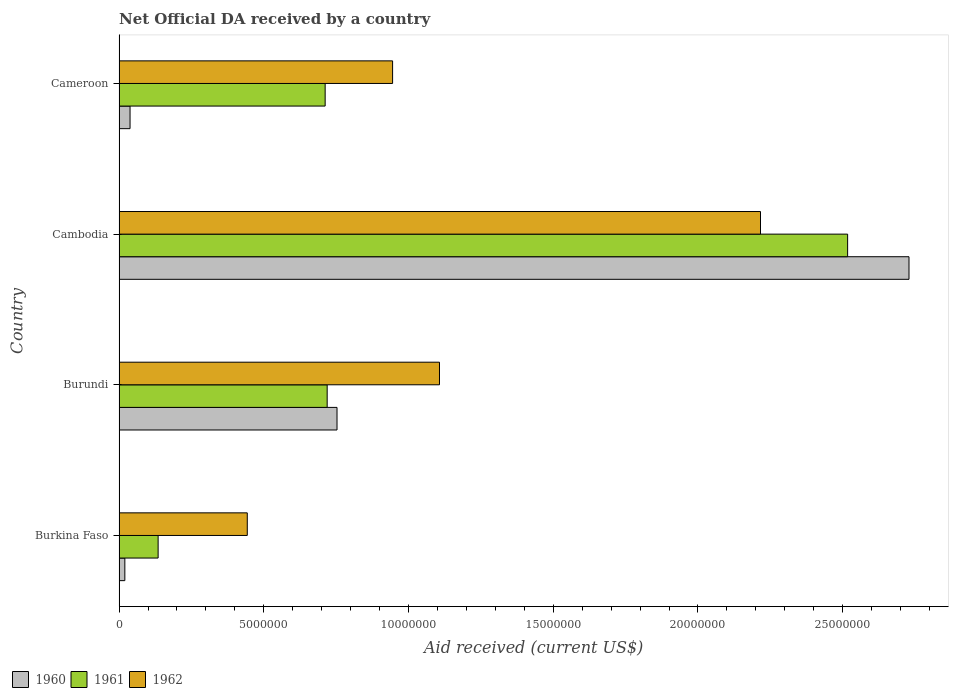How many groups of bars are there?
Your answer should be compact. 4. Are the number of bars per tick equal to the number of legend labels?
Give a very brief answer. Yes. How many bars are there on the 1st tick from the top?
Offer a very short reply. 3. How many bars are there on the 2nd tick from the bottom?
Your response must be concise. 3. What is the label of the 1st group of bars from the top?
Your answer should be very brief. Cameroon. What is the net official development assistance aid received in 1961 in Burkina Faso?
Keep it short and to the point. 1.35e+06. Across all countries, what is the maximum net official development assistance aid received in 1961?
Offer a very short reply. 2.52e+07. Across all countries, what is the minimum net official development assistance aid received in 1961?
Your answer should be very brief. 1.35e+06. In which country was the net official development assistance aid received in 1960 maximum?
Your answer should be very brief. Cambodia. In which country was the net official development assistance aid received in 1960 minimum?
Your answer should be compact. Burkina Faso. What is the total net official development assistance aid received in 1961 in the graph?
Your response must be concise. 4.08e+07. What is the difference between the net official development assistance aid received in 1962 in Burundi and that in Cambodia?
Offer a very short reply. -1.11e+07. What is the difference between the net official development assistance aid received in 1961 in Burundi and the net official development assistance aid received in 1960 in Cameroon?
Your response must be concise. 6.81e+06. What is the average net official development assistance aid received in 1960 per country?
Offer a very short reply. 8.85e+06. What is the difference between the net official development assistance aid received in 1961 and net official development assistance aid received in 1960 in Cambodia?
Make the answer very short. -2.12e+06. In how many countries, is the net official development assistance aid received in 1962 greater than 1000000 US$?
Keep it short and to the point. 4. What is the ratio of the net official development assistance aid received in 1961 in Cambodia to that in Cameroon?
Keep it short and to the point. 3.54. What is the difference between the highest and the second highest net official development assistance aid received in 1960?
Your answer should be very brief. 1.98e+07. What is the difference between the highest and the lowest net official development assistance aid received in 1961?
Make the answer very short. 2.38e+07. Is the sum of the net official development assistance aid received in 1961 in Burkina Faso and Cambodia greater than the maximum net official development assistance aid received in 1960 across all countries?
Give a very brief answer. No. Is it the case that in every country, the sum of the net official development assistance aid received in 1962 and net official development assistance aid received in 1961 is greater than the net official development assistance aid received in 1960?
Offer a terse response. Yes. How many bars are there?
Your response must be concise. 12. Are all the bars in the graph horizontal?
Offer a very short reply. Yes. How many countries are there in the graph?
Offer a terse response. 4. What is the difference between two consecutive major ticks on the X-axis?
Your answer should be compact. 5.00e+06. Does the graph contain any zero values?
Give a very brief answer. No. Where does the legend appear in the graph?
Ensure brevity in your answer.  Bottom left. What is the title of the graph?
Give a very brief answer. Net Official DA received by a country. Does "2014" appear as one of the legend labels in the graph?
Your answer should be very brief. No. What is the label or title of the X-axis?
Offer a very short reply. Aid received (current US$). What is the Aid received (current US$) in 1961 in Burkina Faso?
Offer a terse response. 1.35e+06. What is the Aid received (current US$) in 1962 in Burkina Faso?
Offer a terse response. 4.43e+06. What is the Aid received (current US$) in 1960 in Burundi?
Your response must be concise. 7.53e+06. What is the Aid received (current US$) in 1961 in Burundi?
Your answer should be compact. 7.19e+06. What is the Aid received (current US$) of 1962 in Burundi?
Your answer should be very brief. 1.11e+07. What is the Aid received (current US$) in 1960 in Cambodia?
Provide a succinct answer. 2.73e+07. What is the Aid received (current US$) in 1961 in Cambodia?
Give a very brief answer. 2.52e+07. What is the Aid received (current US$) in 1962 in Cambodia?
Give a very brief answer. 2.22e+07. What is the Aid received (current US$) of 1960 in Cameroon?
Provide a short and direct response. 3.80e+05. What is the Aid received (current US$) of 1961 in Cameroon?
Make the answer very short. 7.12e+06. What is the Aid received (current US$) in 1962 in Cameroon?
Provide a succinct answer. 9.45e+06. Across all countries, what is the maximum Aid received (current US$) of 1960?
Offer a terse response. 2.73e+07. Across all countries, what is the maximum Aid received (current US$) of 1961?
Make the answer very short. 2.52e+07. Across all countries, what is the maximum Aid received (current US$) in 1962?
Give a very brief answer. 2.22e+07. Across all countries, what is the minimum Aid received (current US$) of 1961?
Offer a terse response. 1.35e+06. Across all countries, what is the minimum Aid received (current US$) in 1962?
Offer a very short reply. 4.43e+06. What is the total Aid received (current US$) of 1960 in the graph?
Offer a very short reply. 3.54e+07. What is the total Aid received (current US$) in 1961 in the graph?
Make the answer very short. 4.08e+07. What is the total Aid received (current US$) in 1962 in the graph?
Your response must be concise. 4.71e+07. What is the difference between the Aid received (current US$) in 1960 in Burkina Faso and that in Burundi?
Make the answer very short. -7.33e+06. What is the difference between the Aid received (current US$) in 1961 in Burkina Faso and that in Burundi?
Your answer should be compact. -5.84e+06. What is the difference between the Aid received (current US$) of 1962 in Burkina Faso and that in Burundi?
Ensure brevity in your answer.  -6.64e+06. What is the difference between the Aid received (current US$) in 1960 in Burkina Faso and that in Cambodia?
Your response must be concise. -2.71e+07. What is the difference between the Aid received (current US$) of 1961 in Burkina Faso and that in Cambodia?
Keep it short and to the point. -2.38e+07. What is the difference between the Aid received (current US$) of 1962 in Burkina Faso and that in Cambodia?
Offer a very short reply. -1.77e+07. What is the difference between the Aid received (current US$) in 1960 in Burkina Faso and that in Cameroon?
Give a very brief answer. -1.80e+05. What is the difference between the Aid received (current US$) in 1961 in Burkina Faso and that in Cameroon?
Offer a terse response. -5.77e+06. What is the difference between the Aid received (current US$) in 1962 in Burkina Faso and that in Cameroon?
Make the answer very short. -5.02e+06. What is the difference between the Aid received (current US$) of 1960 in Burundi and that in Cambodia?
Give a very brief answer. -1.98e+07. What is the difference between the Aid received (current US$) of 1961 in Burundi and that in Cambodia?
Offer a very short reply. -1.80e+07. What is the difference between the Aid received (current US$) of 1962 in Burundi and that in Cambodia?
Give a very brief answer. -1.11e+07. What is the difference between the Aid received (current US$) of 1960 in Burundi and that in Cameroon?
Ensure brevity in your answer.  7.15e+06. What is the difference between the Aid received (current US$) of 1961 in Burundi and that in Cameroon?
Give a very brief answer. 7.00e+04. What is the difference between the Aid received (current US$) in 1962 in Burundi and that in Cameroon?
Offer a terse response. 1.62e+06. What is the difference between the Aid received (current US$) in 1960 in Cambodia and that in Cameroon?
Make the answer very short. 2.69e+07. What is the difference between the Aid received (current US$) of 1961 in Cambodia and that in Cameroon?
Your answer should be very brief. 1.80e+07. What is the difference between the Aid received (current US$) of 1962 in Cambodia and that in Cameroon?
Your answer should be very brief. 1.27e+07. What is the difference between the Aid received (current US$) of 1960 in Burkina Faso and the Aid received (current US$) of 1961 in Burundi?
Keep it short and to the point. -6.99e+06. What is the difference between the Aid received (current US$) in 1960 in Burkina Faso and the Aid received (current US$) in 1962 in Burundi?
Keep it short and to the point. -1.09e+07. What is the difference between the Aid received (current US$) of 1961 in Burkina Faso and the Aid received (current US$) of 1962 in Burundi?
Provide a succinct answer. -9.72e+06. What is the difference between the Aid received (current US$) of 1960 in Burkina Faso and the Aid received (current US$) of 1961 in Cambodia?
Provide a succinct answer. -2.50e+07. What is the difference between the Aid received (current US$) in 1960 in Burkina Faso and the Aid received (current US$) in 1962 in Cambodia?
Offer a very short reply. -2.20e+07. What is the difference between the Aid received (current US$) of 1961 in Burkina Faso and the Aid received (current US$) of 1962 in Cambodia?
Your response must be concise. -2.08e+07. What is the difference between the Aid received (current US$) in 1960 in Burkina Faso and the Aid received (current US$) in 1961 in Cameroon?
Your answer should be very brief. -6.92e+06. What is the difference between the Aid received (current US$) in 1960 in Burkina Faso and the Aid received (current US$) in 1962 in Cameroon?
Ensure brevity in your answer.  -9.25e+06. What is the difference between the Aid received (current US$) of 1961 in Burkina Faso and the Aid received (current US$) of 1962 in Cameroon?
Give a very brief answer. -8.10e+06. What is the difference between the Aid received (current US$) in 1960 in Burundi and the Aid received (current US$) in 1961 in Cambodia?
Give a very brief answer. -1.76e+07. What is the difference between the Aid received (current US$) in 1960 in Burundi and the Aid received (current US$) in 1962 in Cambodia?
Ensure brevity in your answer.  -1.46e+07. What is the difference between the Aid received (current US$) of 1961 in Burundi and the Aid received (current US$) of 1962 in Cambodia?
Give a very brief answer. -1.50e+07. What is the difference between the Aid received (current US$) of 1960 in Burundi and the Aid received (current US$) of 1961 in Cameroon?
Offer a terse response. 4.10e+05. What is the difference between the Aid received (current US$) in 1960 in Burundi and the Aid received (current US$) in 1962 in Cameroon?
Provide a short and direct response. -1.92e+06. What is the difference between the Aid received (current US$) of 1961 in Burundi and the Aid received (current US$) of 1962 in Cameroon?
Offer a terse response. -2.26e+06. What is the difference between the Aid received (current US$) in 1960 in Cambodia and the Aid received (current US$) in 1961 in Cameroon?
Provide a succinct answer. 2.02e+07. What is the difference between the Aid received (current US$) in 1960 in Cambodia and the Aid received (current US$) in 1962 in Cameroon?
Ensure brevity in your answer.  1.78e+07. What is the difference between the Aid received (current US$) of 1961 in Cambodia and the Aid received (current US$) of 1962 in Cameroon?
Give a very brief answer. 1.57e+07. What is the average Aid received (current US$) of 1960 per country?
Give a very brief answer. 8.85e+06. What is the average Aid received (current US$) in 1961 per country?
Offer a terse response. 1.02e+07. What is the average Aid received (current US$) in 1962 per country?
Make the answer very short. 1.18e+07. What is the difference between the Aid received (current US$) of 1960 and Aid received (current US$) of 1961 in Burkina Faso?
Offer a terse response. -1.15e+06. What is the difference between the Aid received (current US$) of 1960 and Aid received (current US$) of 1962 in Burkina Faso?
Your response must be concise. -4.23e+06. What is the difference between the Aid received (current US$) of 1961 and Aid received (current US$) of 1962 in Burkina Faso?
Make the answer very short. -3.08e+06. What is the difference between the Aid received (current US$) in 1960 and Aid received (current US$) in 1962 in Burundi?
Give a very brief answer. -3.54e+06. What is the difference between the Aid received (current US$) in 1961 and Aid received (current US$) in 1962 in Burundi?
Ensure brevity in your answer.  -3.88e+06. What is the difference between the Aid received (current US$) of 1960 and Aid received (current US$) of 1961 in Cambodia?
Make the answer very short. 2.12e+06. What is the difference between the Aid received (current US$) in 1960 and Aid received (current US$) in 1962 in Cambodia?
Your answer should be compact. 5.13e+06. What is the difference between the Aid received (current US$) in 1961 and Aid received (current US$) in 1962 in Cambodia?
Offer a very short reply. 3.01e+06. What is the difference between the Aid received (current US$) in 1960 and Aid received (current US$) in 1961 in Cameroon?
Keep it short and to the point. -6.74e+06. What is the difference between the Aid received (current US$) of 1960 and Aid received (current US$) of 1962 in Cameroon?
Provide a succinct answer. -9.07e+06. What is the difference between the Aid received (current US$) in 1961 and Aid received (current US$) in 1962 in Cameroon?
Provide a short and direct response. -2.33e+06. What is the ratio of the Aid received (current US$) of 1960 in Burkina Faso to that in Burundi?
Your response must be concise. 0.03. What is the ratio of the Aid received (current US$) of 1961 in Burkina Faso to that in Burundi?
Your answer should be very brief. 0.19. What is the ratio of the Aid received (current US$) in 1962 in Burkina Faso to that in Burundi?
Provide a succinct answer. 0.4. What is the ratio of the Aid received (current US$) of 1960 in Burkina Faso to that in Cambodia?
Offer a very short reply. 0.01. What is the ratio of the Aid received (current US$) of 1961 in Burkina Faso to that in Cambodia?
Your response must be concise. 0.05. What is the ratio of the Aid received (current US$) in 1962 in Burkina Faso to that in Cambodia?
Make the answer very short. 0.2. What is the ratio of the Aid received (current US$) of 1960 in Burkina Faso to that in Cameroon?
Ensure brevity in your answer.  0.53. What is the ratio of the Aid received (current US$) of 1961 in Burkina Faso to that in Cameroon?
Your answer should be compact. 0.19. What is the ratio of the Aid received (current US$) of 1962 in Burkina Faso to that in Cameroon?
Provide a short and direct response. 0.47. What is the ratio of the Aid received (current US$) in 1960 in Burundi to that in Cambodia?
Keep it short and to the point. 0.28. What is the ratio of the Aid received (current US$) of 1961 in Burundi to that in Cambodia?
Offer a terse response. 0.29. What is the ratio of the Aid received (current US$) of 1962 in Burundi to that in Cambodia?
Your response must be concise. 0.5. What is the ratio of the Aid received (current US$) in 1960 in Burundi to that in Cameroon?
Ensure brevity in your answer.  19.82. What is the ratio of the Aid received (current US$) of 1961 in Burundi to that in Cameroon?
Ensure brevity in your answer.  1.01. What is the ratio of the Aid received (current US$) in 1962 in Burundi to that in Cameroon?
Ensure brevity in your answer.  1.17. What is the ratio of the Aid received (current US$) in 1960 in Cambodia to that in Cameroon?
Offer a very short reply. 71.82. What is the ratio of the Aid received (current US$) in 1961 in Cambodia to that in Cameroon?
Make the answer very short. 3.54. What is the ratio of the Aid received (current US$) of 1962 in Cambodia to that in Cameroon?
Provide a succinct answer. 2.35. What is the difference between the highest and the second highest Aid received (current US$) in 1960?
Your answer should be very brief. 1.98e+07. What is the difference between the highest and the second highest Aid received (current US$) in 1961?
Keep it short and to the point. 1.80e+07. What is the difference between the highest and the second highest Aid received (current US$) in 1962?
Offer a terse response. 1.11e+07. What is the difference between the highest and the lowest Aid received (current US$) of 1960?
Keep it short and to the point. 2.71e+07. What is the difference between the highest and the lowest Aid received (current US$) of 1961?
Offer a terse response. 2.38e+07. What is the difference between the highest and the lowest Aid received (current US$) of 1962?
Offer a very short reply. 1.77e+07. 